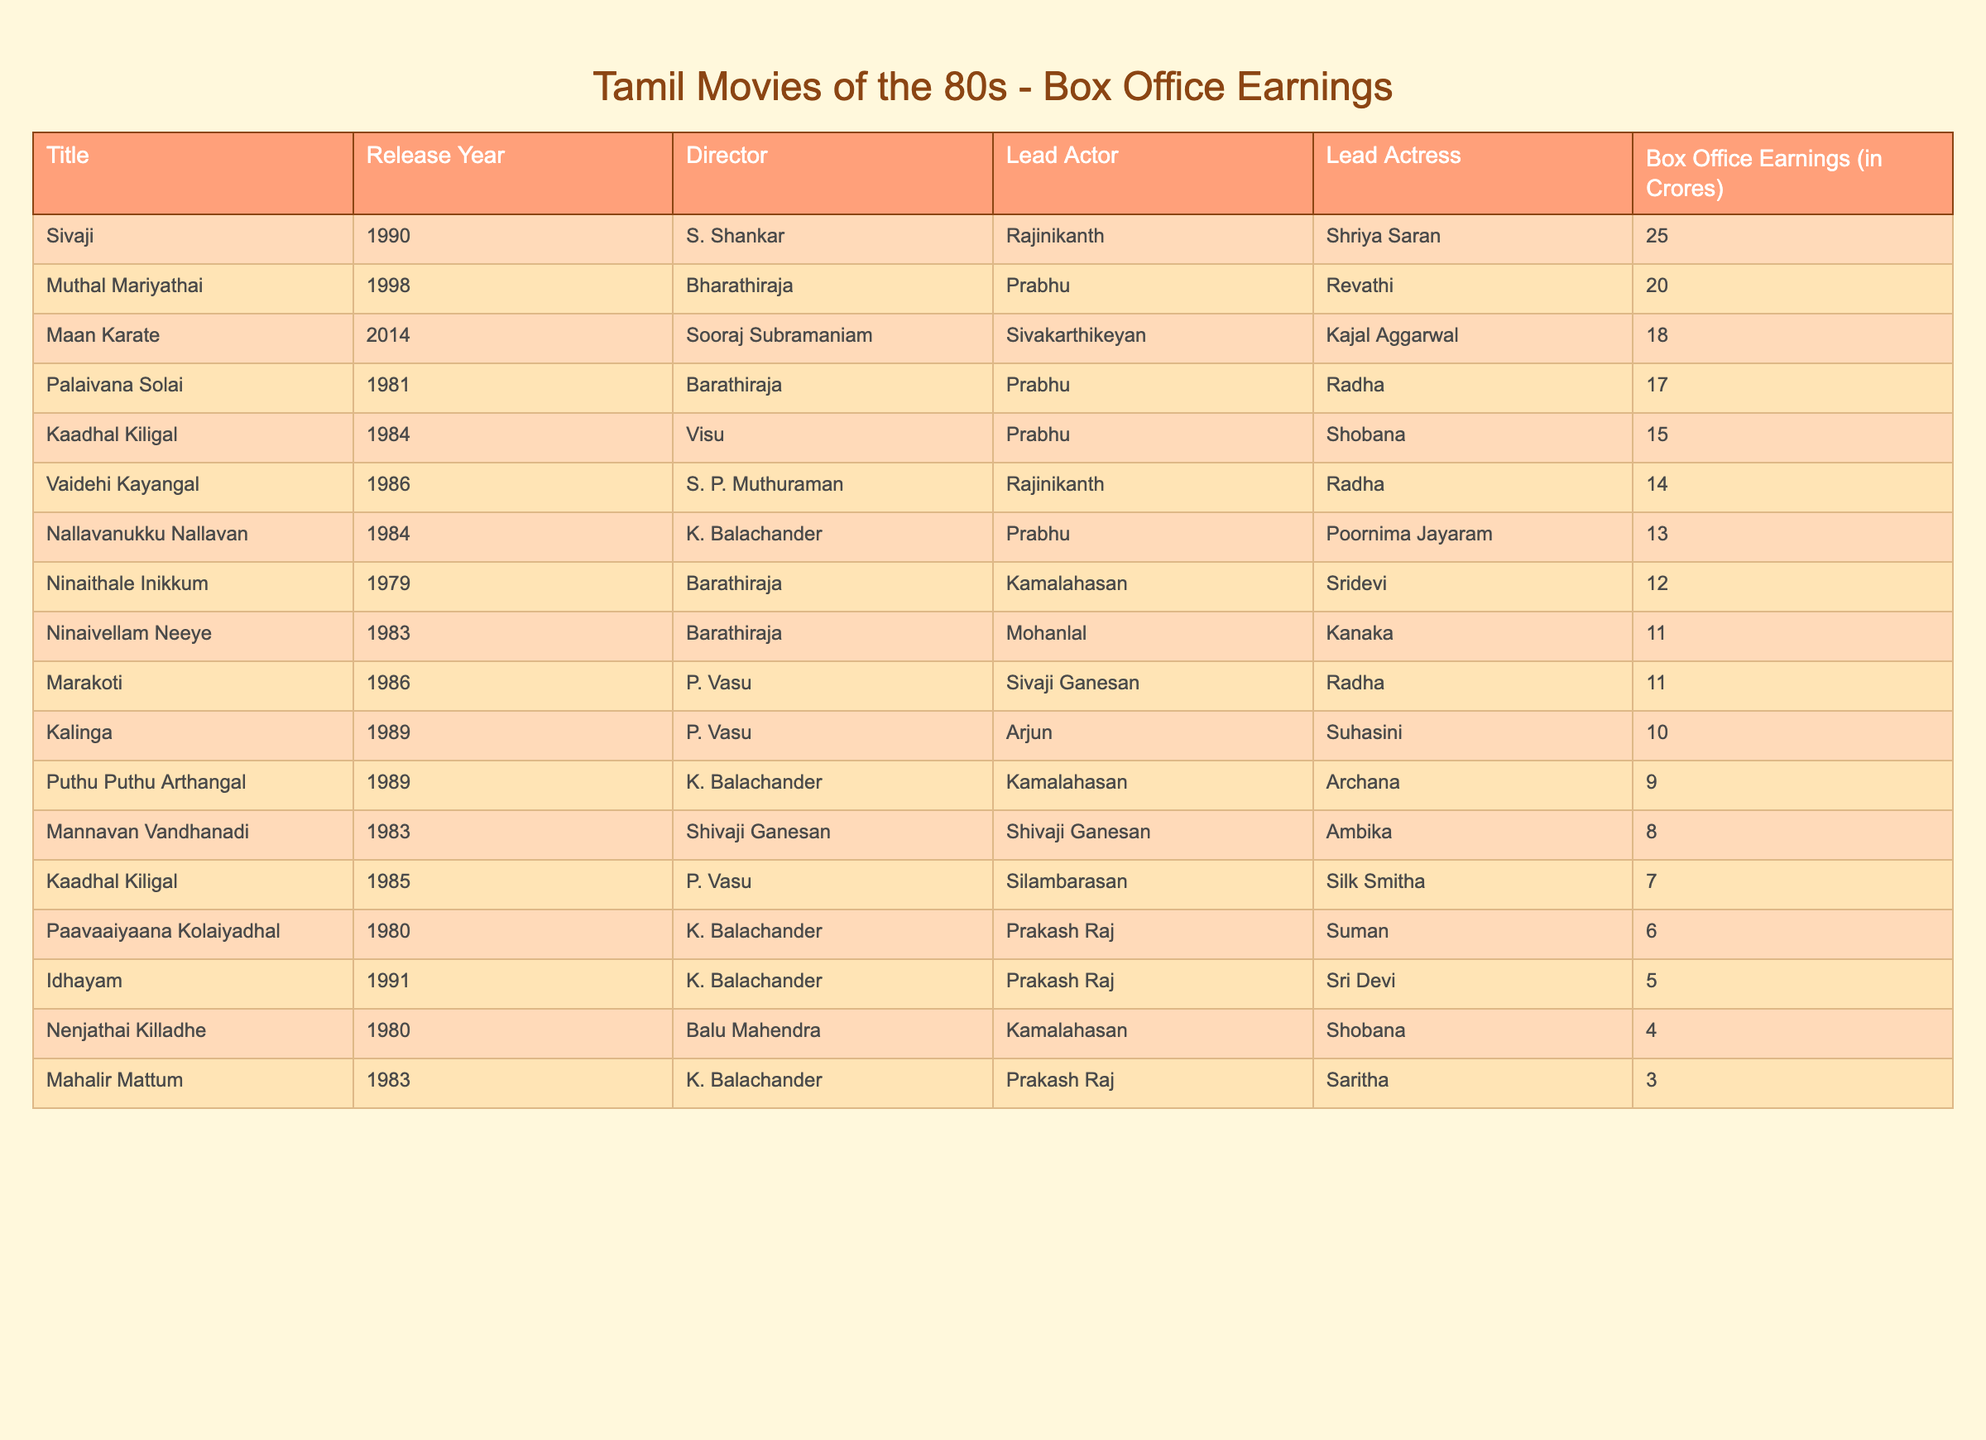What is the title of the movie that earned the highest box office in the table? By reviewing the "Box Office Earnings (in Crores)" column, the highest value is 25 crores. The corresponding title of the movie is "Sivaji."
Answer: Sivaji Which director made the most movies in the 1980s according to this table? Counting the instances of each director in the "Director" column, K. Balachander appears four times, which is more than any other director listed.
Answer: K. Balachander What were the box office earnings of "Mannavan Vandhanadi"? By checking the table, the box office earnings for "Mannavan Vandhanadi" is found in the respective row, which states 8 crores.
Answer: 8 crores What is the average box office earnings of Tamil movies directed by K. Balachander in this table? First, we find the box office earnings of the movies directed by K. Balachander: (6 + 4 + 3 + 9) = 22 crores. There are four movies, so the average is 22/4 = 5.5 crores.
Answer: 5.5 crores Did any movie released in 1984 earn less than 10 crores at the box office? Looking at the entries from the year 1984, "Nallavanukku Nallavan" (13 crores) and "Kaadhal Kiligal" (15 crores) exceed 10 crores, but there is no movie from that year that earned less than 10 crores.
Answer: No What is the difference in box office earnings between "Kaadhal Kiligal" (1984) and "Nenjathai Killadhe"? The earnings of "Kaadhal Kiligal" is 15 crores and "Nenjathai Killadhe" is 4 crores. The difference is 15 - 4 = 11 crores.
Answer: 11 crores Which movie features both Rajinikanth and was released before 1990? Based on the table, "Vaidehi Kayangal" (1986) features Rajinikanth and is also released before 1990.
Answer: Vaidehi Kayangal How many movies had box office earnings greater than 10 crores? Reviewing the "Box Office Earnings (in Crores)" column, the movies with earnings over 10 crores are as follows: Sivaji (25), Kaadhal Kiligal (15), Vaidehi Kayangal (14), Nallavanukku Nallavan (13), Palaivana Solai (17), and Kaadhal Kiligal (1984) (which is 15). Counting these, we get 6 movies.
Answer: 6 movies Is there a movie where Prabhu is the lead actor and it earned over 10 crores? Looking through the entries where Prabhu is the lead actor, "Kaadhal Kiligal" (1984) earned 15 crores and "Nallavanukku Nallavan" (1984) earned 13 crores. Both earnings are over 10 crores.
Answer: Yes What is the total box office earnings of all movies in 1983? The movies from 1983 in the table are "Mannavan Vandhanadi" (8), "Ninaivellam Neeye" (11), "Mahalir Mattum" (3), so the total earnings is 8 + 11 + 3 = 22 crores.
Answer: 22 crores 